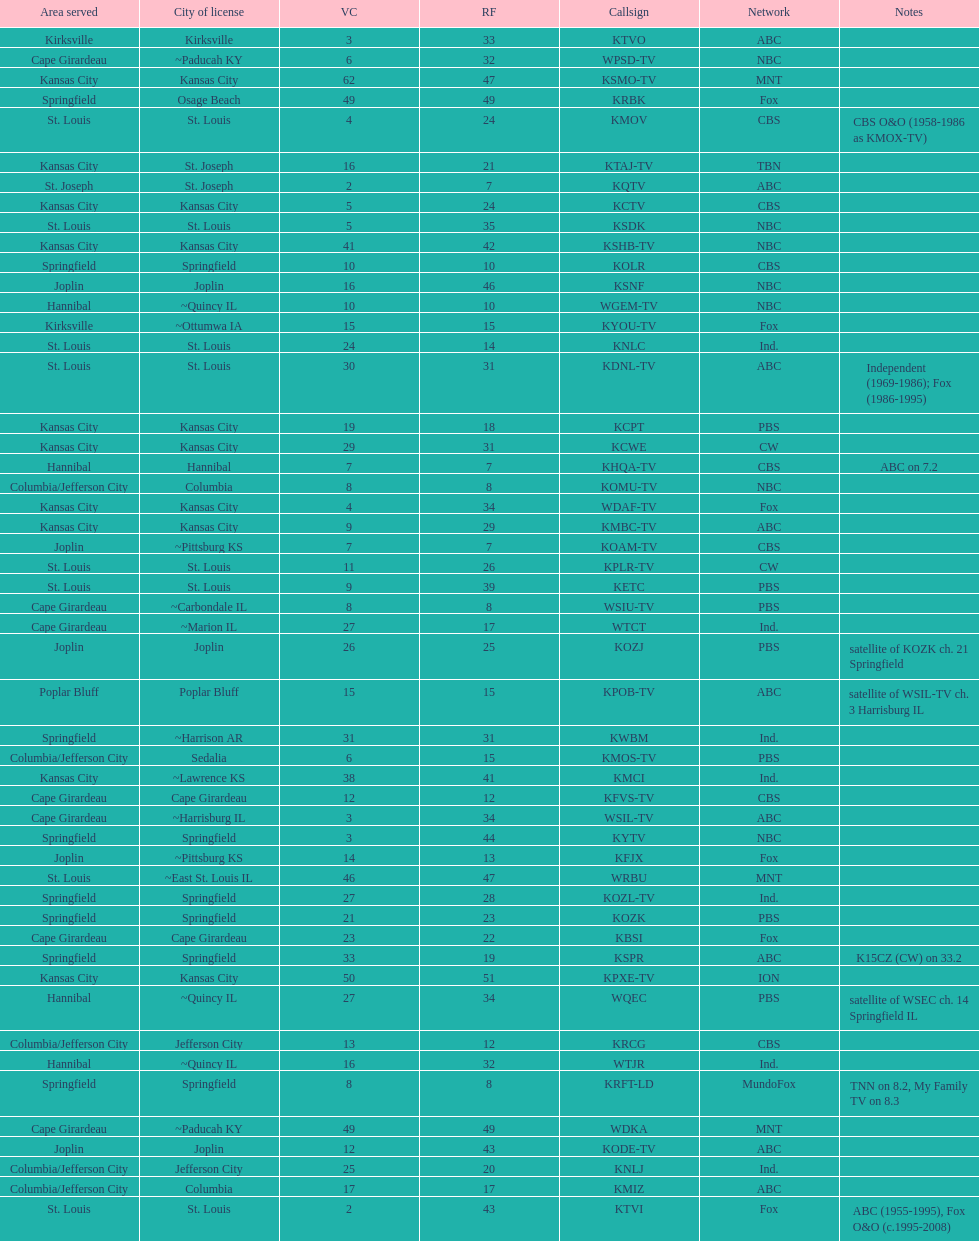Kode-tv and wsil-tv both are a part of which network? ABC. 